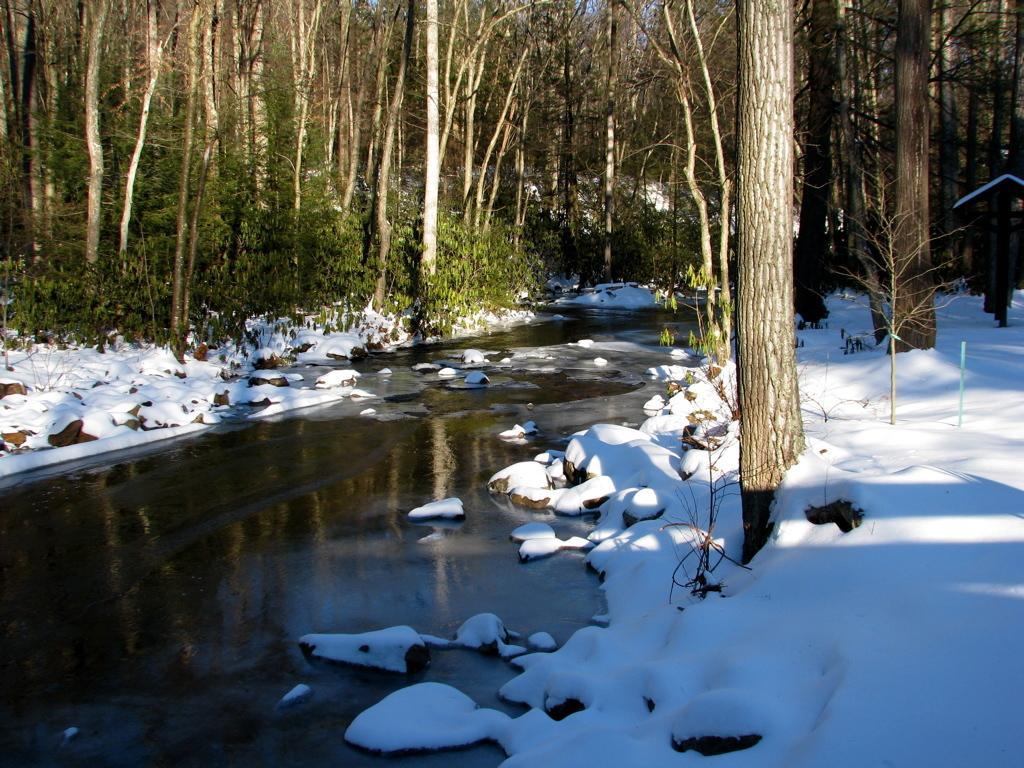Please provide a concise description of this image. In this image, we can see trees and plants and there is a stand. At the bottom, there is water and snow and there are rocks. 